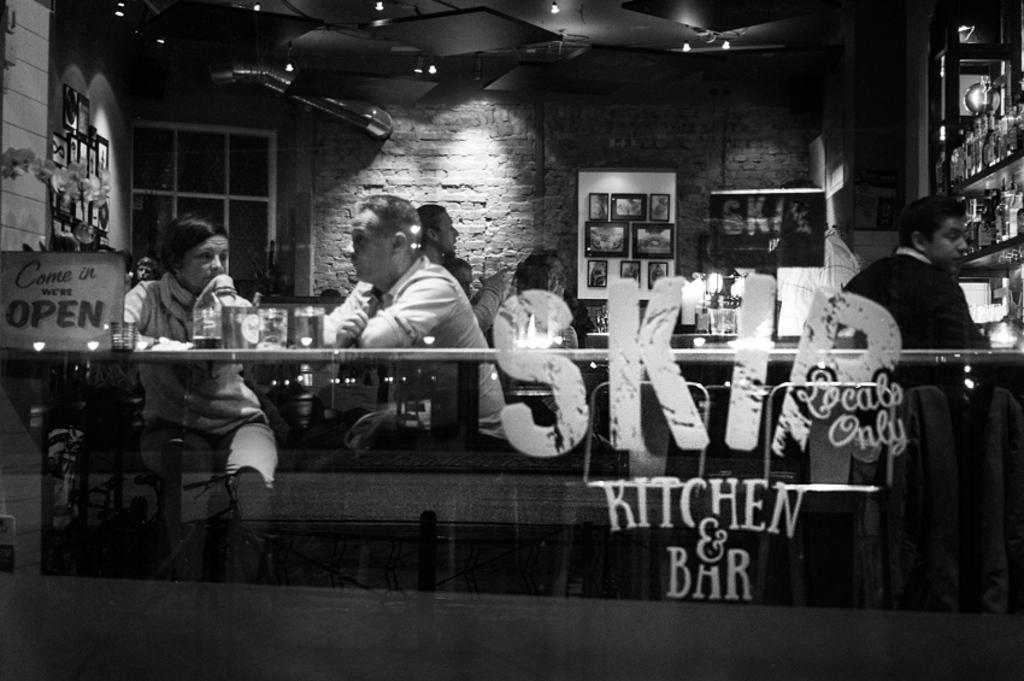Describe this image in one or two sentences. This persons are sitting on a chair. In-front of them there are tables. On a table there are cups. This is window with glasses. On a wall there are different type of pictures. Roof with lights. This is a rack. 